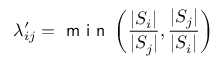<formula> <loc_0><loc_0><loc_500><loc_500>\lambda _ { i j } ^ { \prime } = \min \left ( \frac { | S _ { i } | } { | S _ { j } | } , \frac { | S _ { j } | } { | S _ { i } | } \right )</formula> 